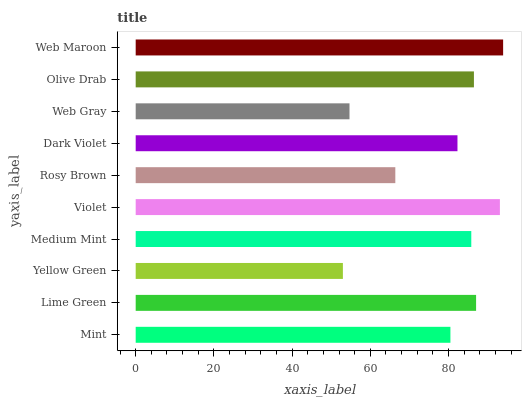Is Yellow Green the minimum?
Answer yes or no. Yes. Is Web Maroon the maximum?
Answer yes or no. Yes. Is Lime Green the minimum?
Answer yes or no. No. Is Lime Green the maximum?
Answer yes or no. No. Is Lime Green greater than Mint?
Answer yes or no. Yes. Is Mint less than Lime Green?
Answer yes or no. Yes. Is Mint greater than Lime Green?
Answer yes or no. No. Is Lime Green less than Mint?
Answer yes or no. No. Is Medium Mint the high median?
Answer yes or no. Yes. Is Dark Violet the low median?
Answer yes or no. Yes. Is Rosy Brown the high median?
Answer yes or no. No. Is Web Maroon the low median?
Answer yes or no. No. 